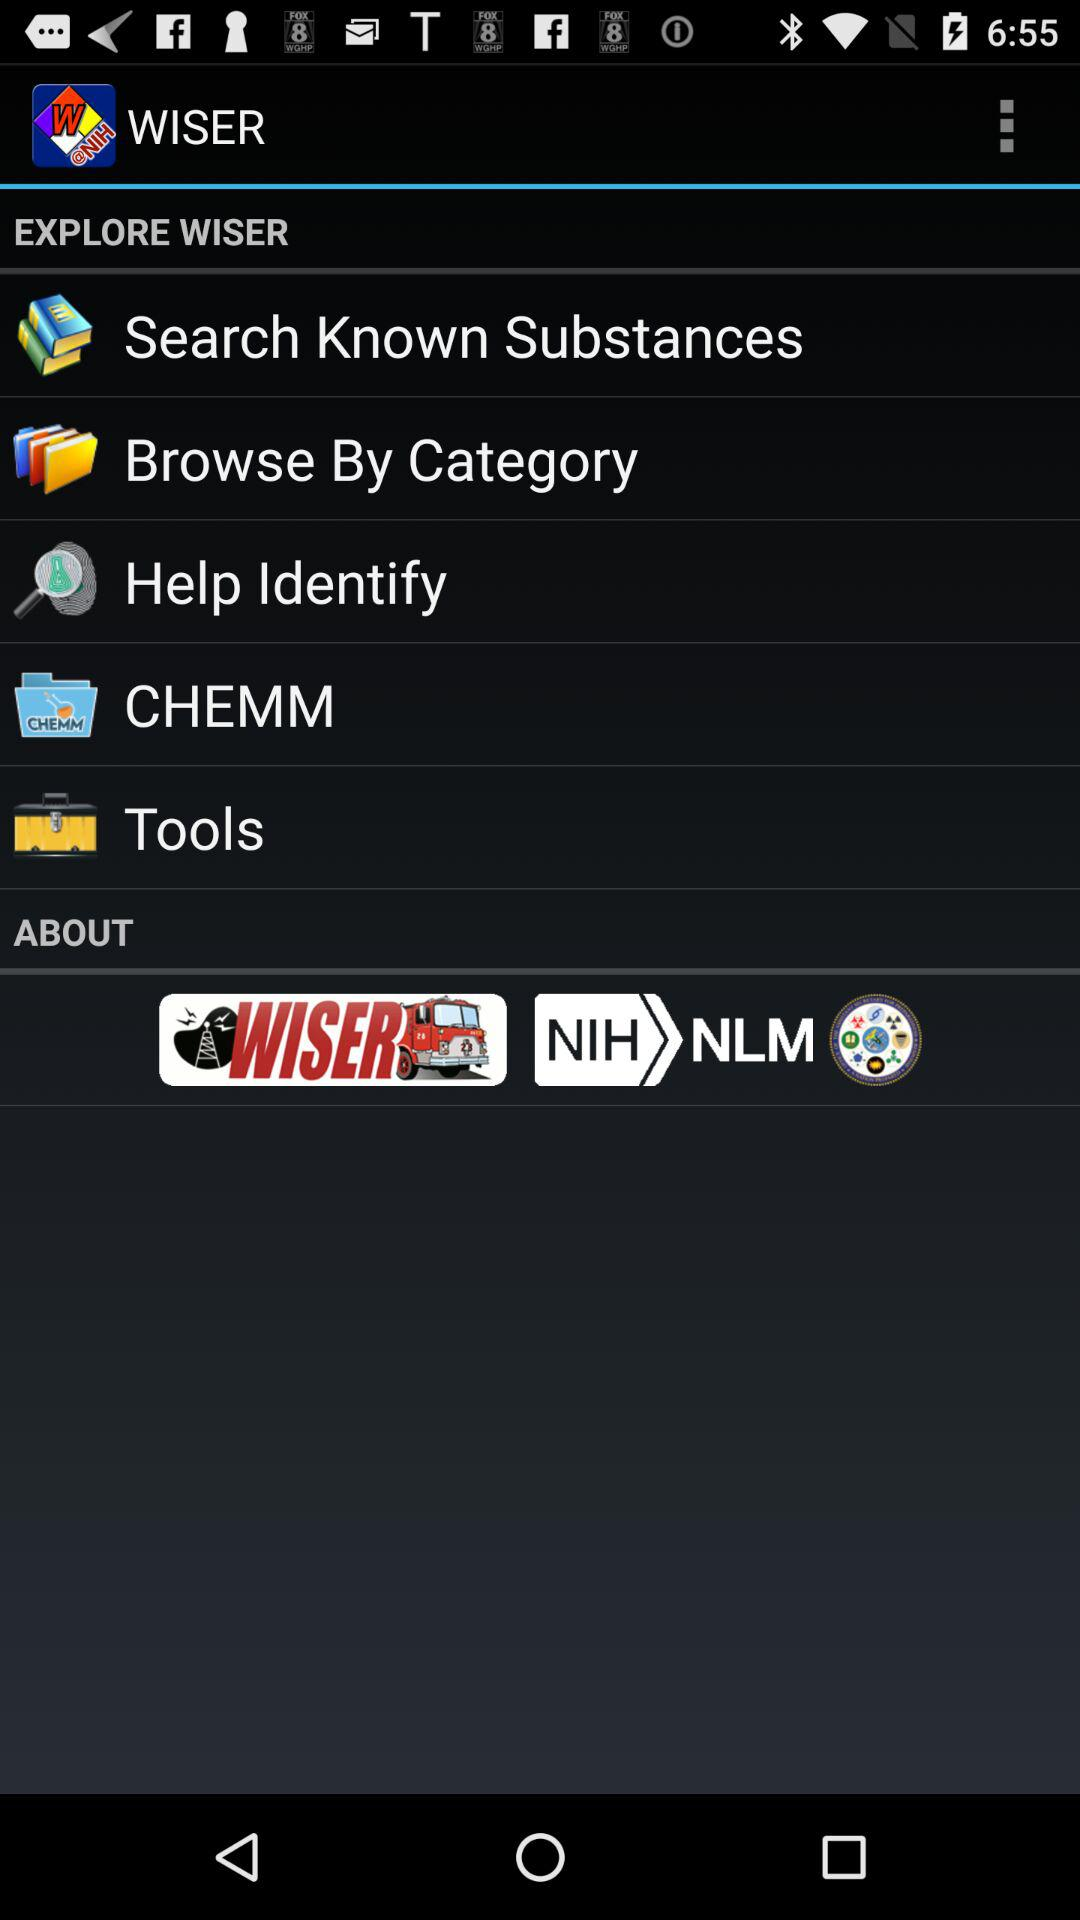What is the name of the application? The name of the application is "WISER". 